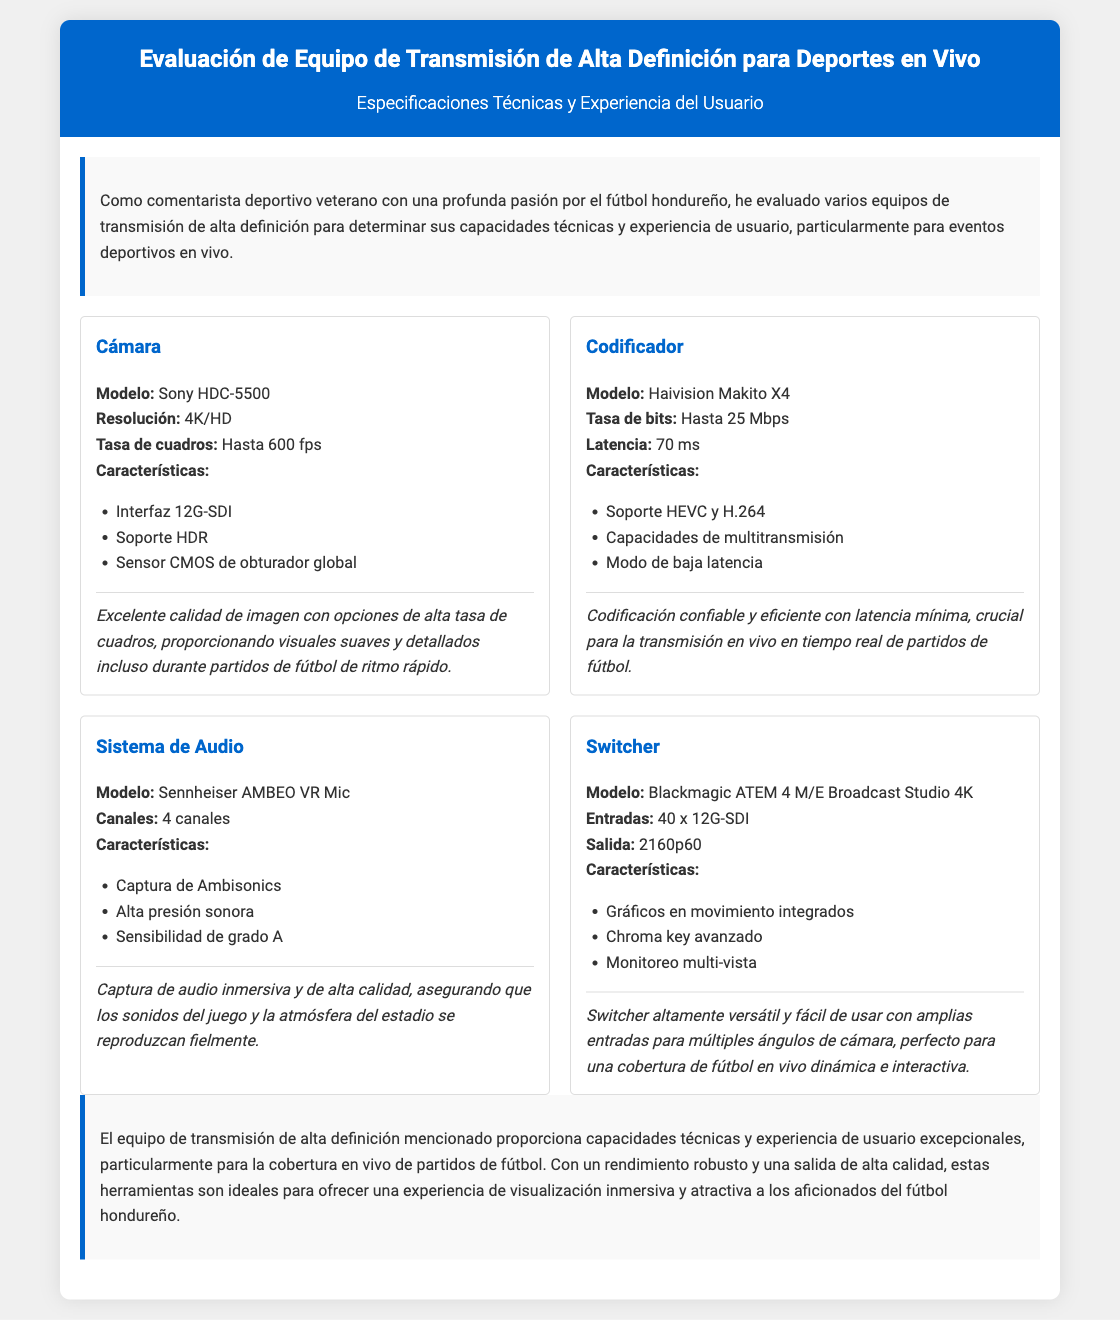¿Qué modelo de cámara se menciona? El modelo de cámara es uno de los detalles técnicos destacados en el documento.
Answer: Sony HDC-5500 ¿Cuál es la tasa de cuadros máxima que soporta la cámara? La tasa de cuadros máxima es un aspecto importante para la calidad de la transmisión en eventos deportivos.
Answer: Hasta 600 fps ¿Qué tipo de micrófono se utiliza en el sistema de audio? Esta pregunta se refiere a la especificación del micrófono en el sistema de audio mencionado en el documento.
Answer: Sennheiser AMBEO VR Mic ¿Cuántos canales tiene el sistema de audio? Este dato refleja las capacidades del sistema de audio al proporcionar información sobre su diseño.
Answer: 4 canales ¿Cuál es la latencia del codificador? La latencia es un factor crítico en la transmisión en vivo de deportes, lo que hace importante esta especificación.
Answer: 70 ms ¿Por qué es importante el modo de baja latencia en el codificador? Este aspecto requiere entender la relevancia de la latencia en la transmisión en vivo de eventos deportivos.
Answer: Crucial para la transmisión en vivo en tiempo real ¿Qué tipo de soporte tiene la cámara? Este detalle muestra las capacidades de video del equipo de transmisión.
Answer: Soporte HDR ¿Cuál es la salida máxima que puede manejar el switcher? La salida máxima es un aspecto técnico clave que indica la capacidad del switcher en la transmisión.
Answer: 2160p60 